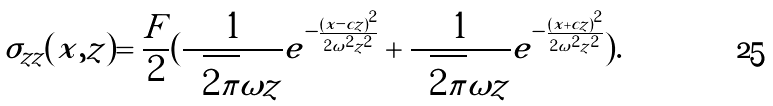<formula> <loc_0><loc_0><loc_500><loc_500>\sigma _ { z z } ( x , z ) = \frac { F } { 2 } ( \frac { 1 } { \sqrt { 2 \pi } \omega z } e ^ { - \frac { ( x - c z ) ^ { 2 } } { 2 \omega ^ { 2 } z ^ { 2 } } } + \frac { 1 } { \sqrt { 2 \pi } \omega z } e ^ { - \frac { ( x + c z ) ^ { 2 } } { 2 \omega ^ { 2 } z ^ { 2 } } } ) .</formula> 